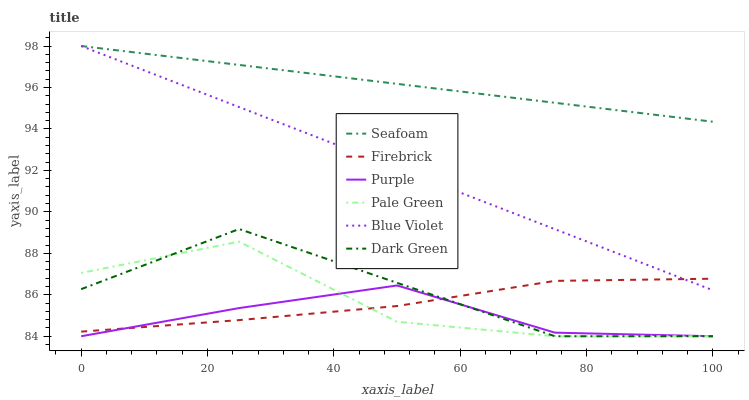Does Purple have the minimum area under the curve?
Answer yes or no. Yes. Does Seafoam have the maximum area under the curve?
Answer yes or no. Yes. Does Firebrick have the minimum area under the curve?
Answer yes or no. No. Does Firebrick have the maximum area under the curve?
Answer yes or no. No. Is Blue Violet the smoothest?
Answer yes or no. Yes. Is Pale Green the roughest?
Answer yes or no. Yes. Is Firebrick the smoothest?
Answer yes or no. No. Is Firebrick the roughest?
Answer yes or no. No. Does Purple have the lowest value?
Answer yes or no. Yes. Does Firebrick have the lowest value?
Answer yes or no. No. Does Blue Violet have the highest value?
Answer yes or no. Yes. Does Firebrick have the highest value?
Answer yes or no. No. Is Pale Green less than Seafoam?
Answer yes or no. Yes. Is Seafoam greater than Pale Green?
Answer yes or no. Yes. Does Blue Violet intersect Firebrick?
Answer yes or no. Yes. Is Blue Violet less than Firebrick?
Answer yes or no. No. Is Blue Violet greater than Firebrick?
Answer yes or no. No. Does Pale Green intersect Seafoam?
Answer yes or no. No. 